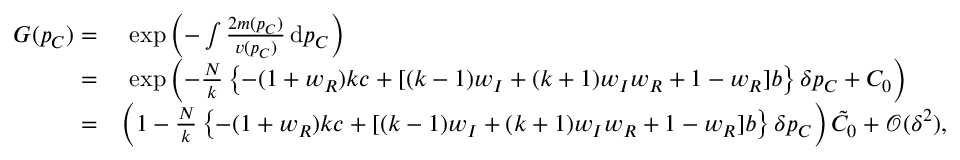Convert formula to latex. <formula><loc_0><loc_0><loc_500><loc_500>\begin{array} { r l } { G ( p _ { C } ) = } & { \exp { \left ( - \int { \frac { 2 m ( p _ { C } ) } { v ( p _ { C } ) } } \, d p _ { C } \right ) } } \\ { = } & { \exp { \left ( - \frac { N } { k } \left \{ - ( 1 + w _ { R } ) k c + [ ( k - 1 ) w _ { I } + ( k + 1 ) w _ { I } w _ { R } + 1 - w _ { R } ] b \right \} \delta p _ { C } + C _ { 0 } \right ) } } \\ { = } & { \left ( 1 - \frac { N } { k } \left \{ - ( 1 + w _ { R } ) k c + [ ( k - 1 ) w _ { I } + ( k + 1 ) w _ { I } w _ { R } + 1 - w _ { R } ] b \right \} \delta p _ { C } \right ) \tilde { C } _ { 0 } + \mathcal { O } ( \delta ^ { 2 } ) , } \end{array}</formula> 